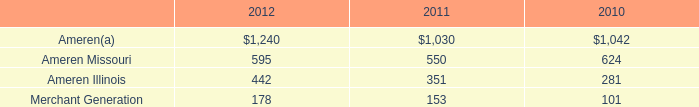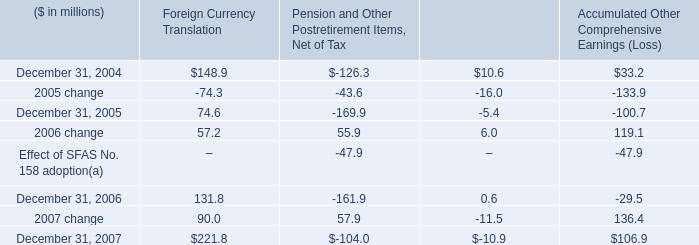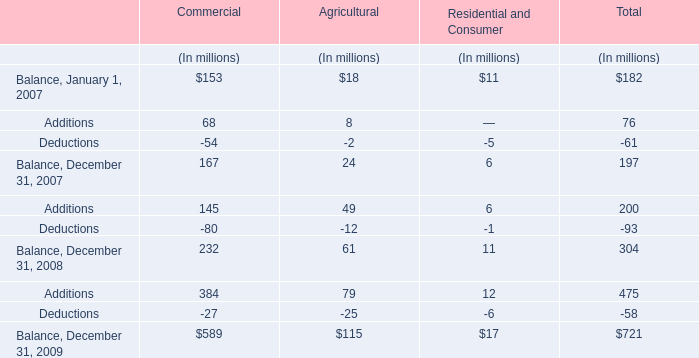what was the percentage change in accumulated other comprehensive earnings ( loss ) between 2006 and 2007?\\n 
Computations: ((106.9 - -29.5) / 29.5)
Answer: 4.62373. 